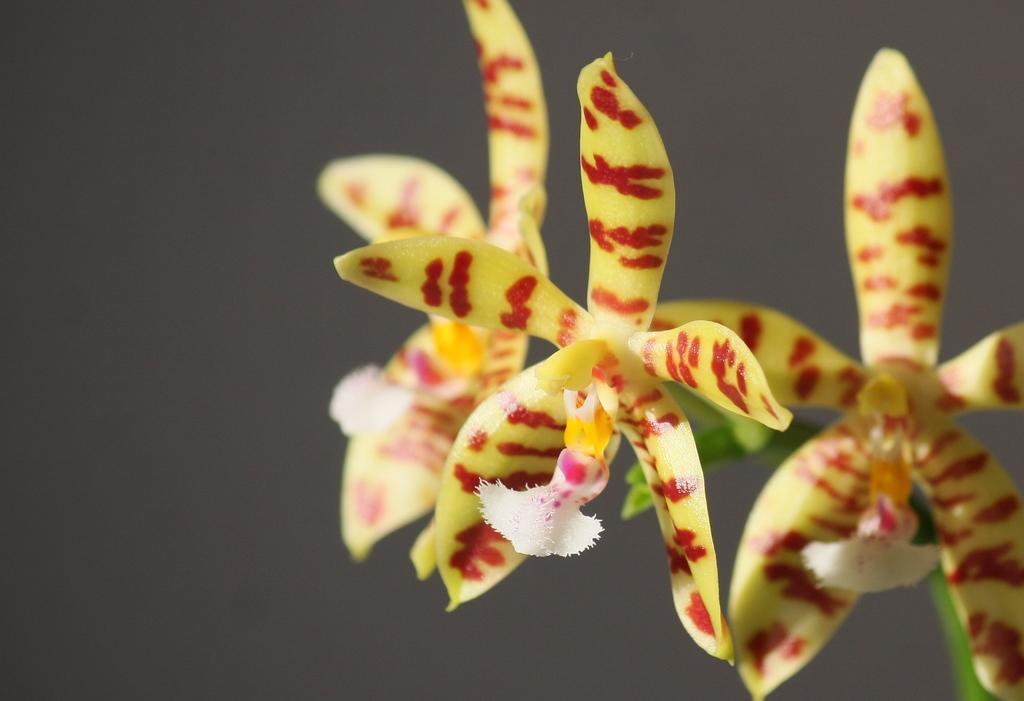Could you give a brief overview of what you see in this image? In this picture we can see yellow color flowers here. 